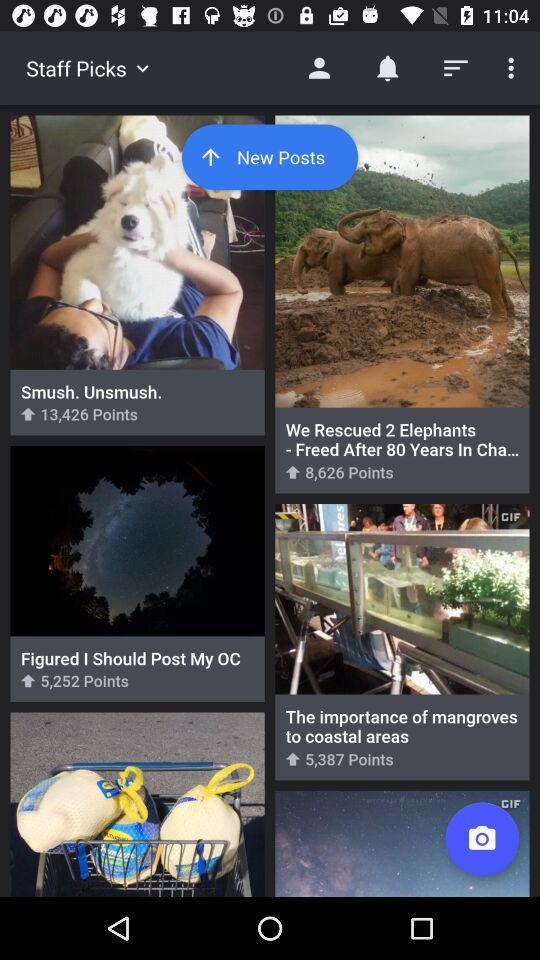How many points are there for "My OC"? There are 5,252 points for "My OC". 